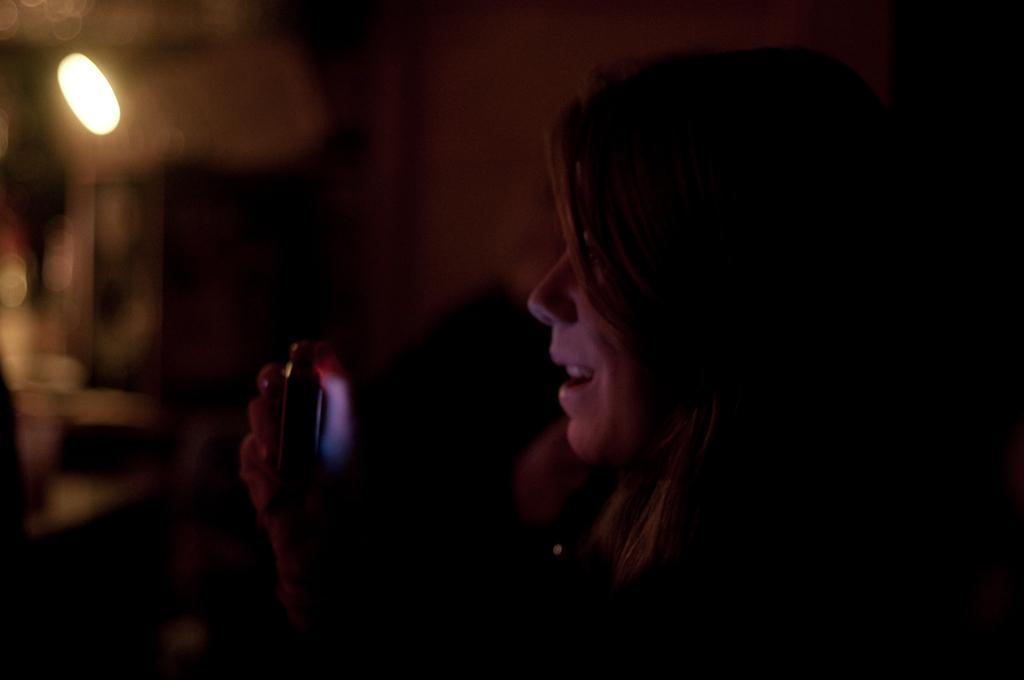Please provide a concise description of this image. In this picture we can see a woman and in the background we can see it is dark. 